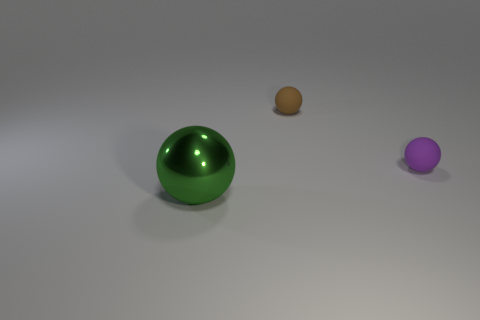Add 1 brown matte spheres. How many objects exist? 4 Subtract all green shiny spheres. Subtract all matte spheres. How many objects are left? 0 Add 3 small purple rubber spheres. How many small purple rubber spheres are left? 4 Add 2 big green metal spheres. How many big green metal spheres exist? 3 Subtract 0 green cylinders. How many objects are left? 3 